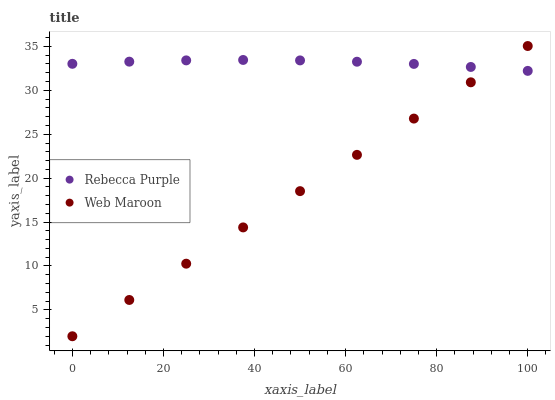Does Web Maroon have the minimum area under the curve?
Answer yes or no. Yes. Does Rebecca Purple have the maximum area under the curve?
Answer yes or no. Yes. Does Rebecca Purple have the minimum area under the curve?
Answer yes or no. No. Is Web Maroon the smoothest?
Answer yes or no. Yes. Is Rebecca Purple the roughest?
Answer yes or no. Yes. Is Rebecca Purple the smoothest?
Answer yes or no. No. Does Web Maroon have the lowest value?
Answer yes or no. Yes. Does Rebecca Purple have the lowest value?
Answer yes or no. No. Does Web Maroon have the highest value?
Answer yes or no. Yes. Does Rebecca Purple have the highest value?
Answer yes or no. No. Does Rebecca Purple intersect Web Maroon?
Answer yes or no. Yes. Is Rebecca Purple less than Web Maroon?
Answer yes or no. No. Is Rebecca Purple greater than Web Maroon?
Answer yes or no. No. 